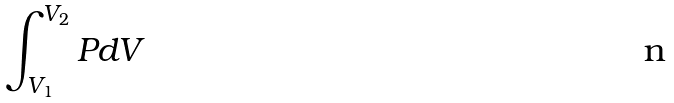Convert formula to latex. <formula><loc_0><loc_0><loc_500><loc_500>\int _ { V _ { 1 } } ^ { V _ { 2 } } P d V</formula> 